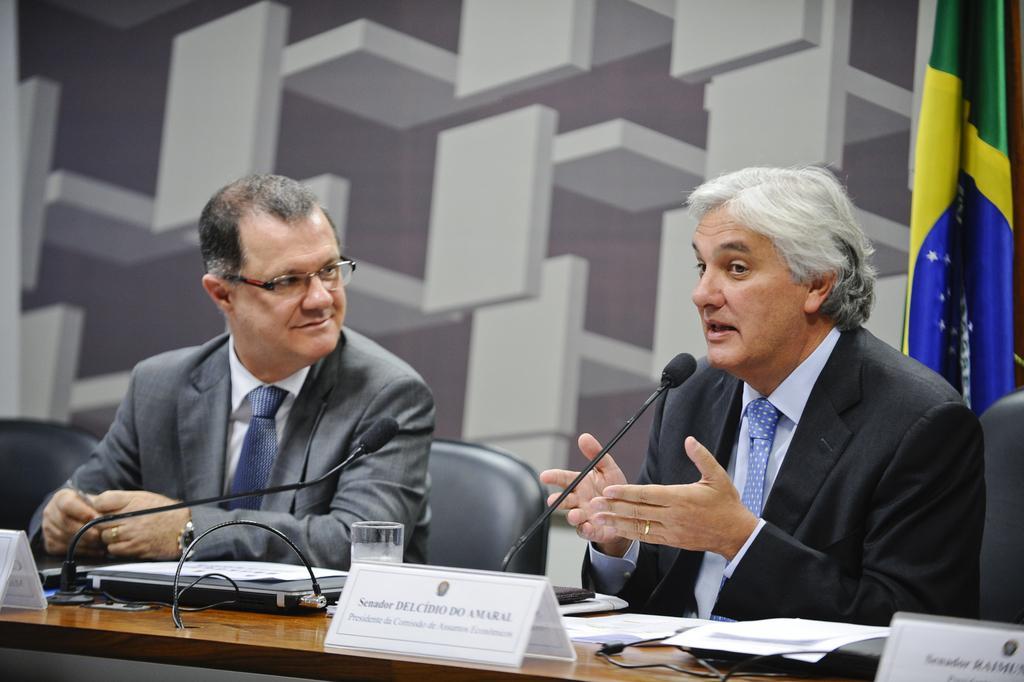How would you summarize this image in a sentence or two? In this image I can see two men are sitting on chairs. I can see both of them are wearing formal dress and I can see he is wearing specs. I can also see few boards, few white colour papers, few mics, a glass and in the background I can see a flag. 